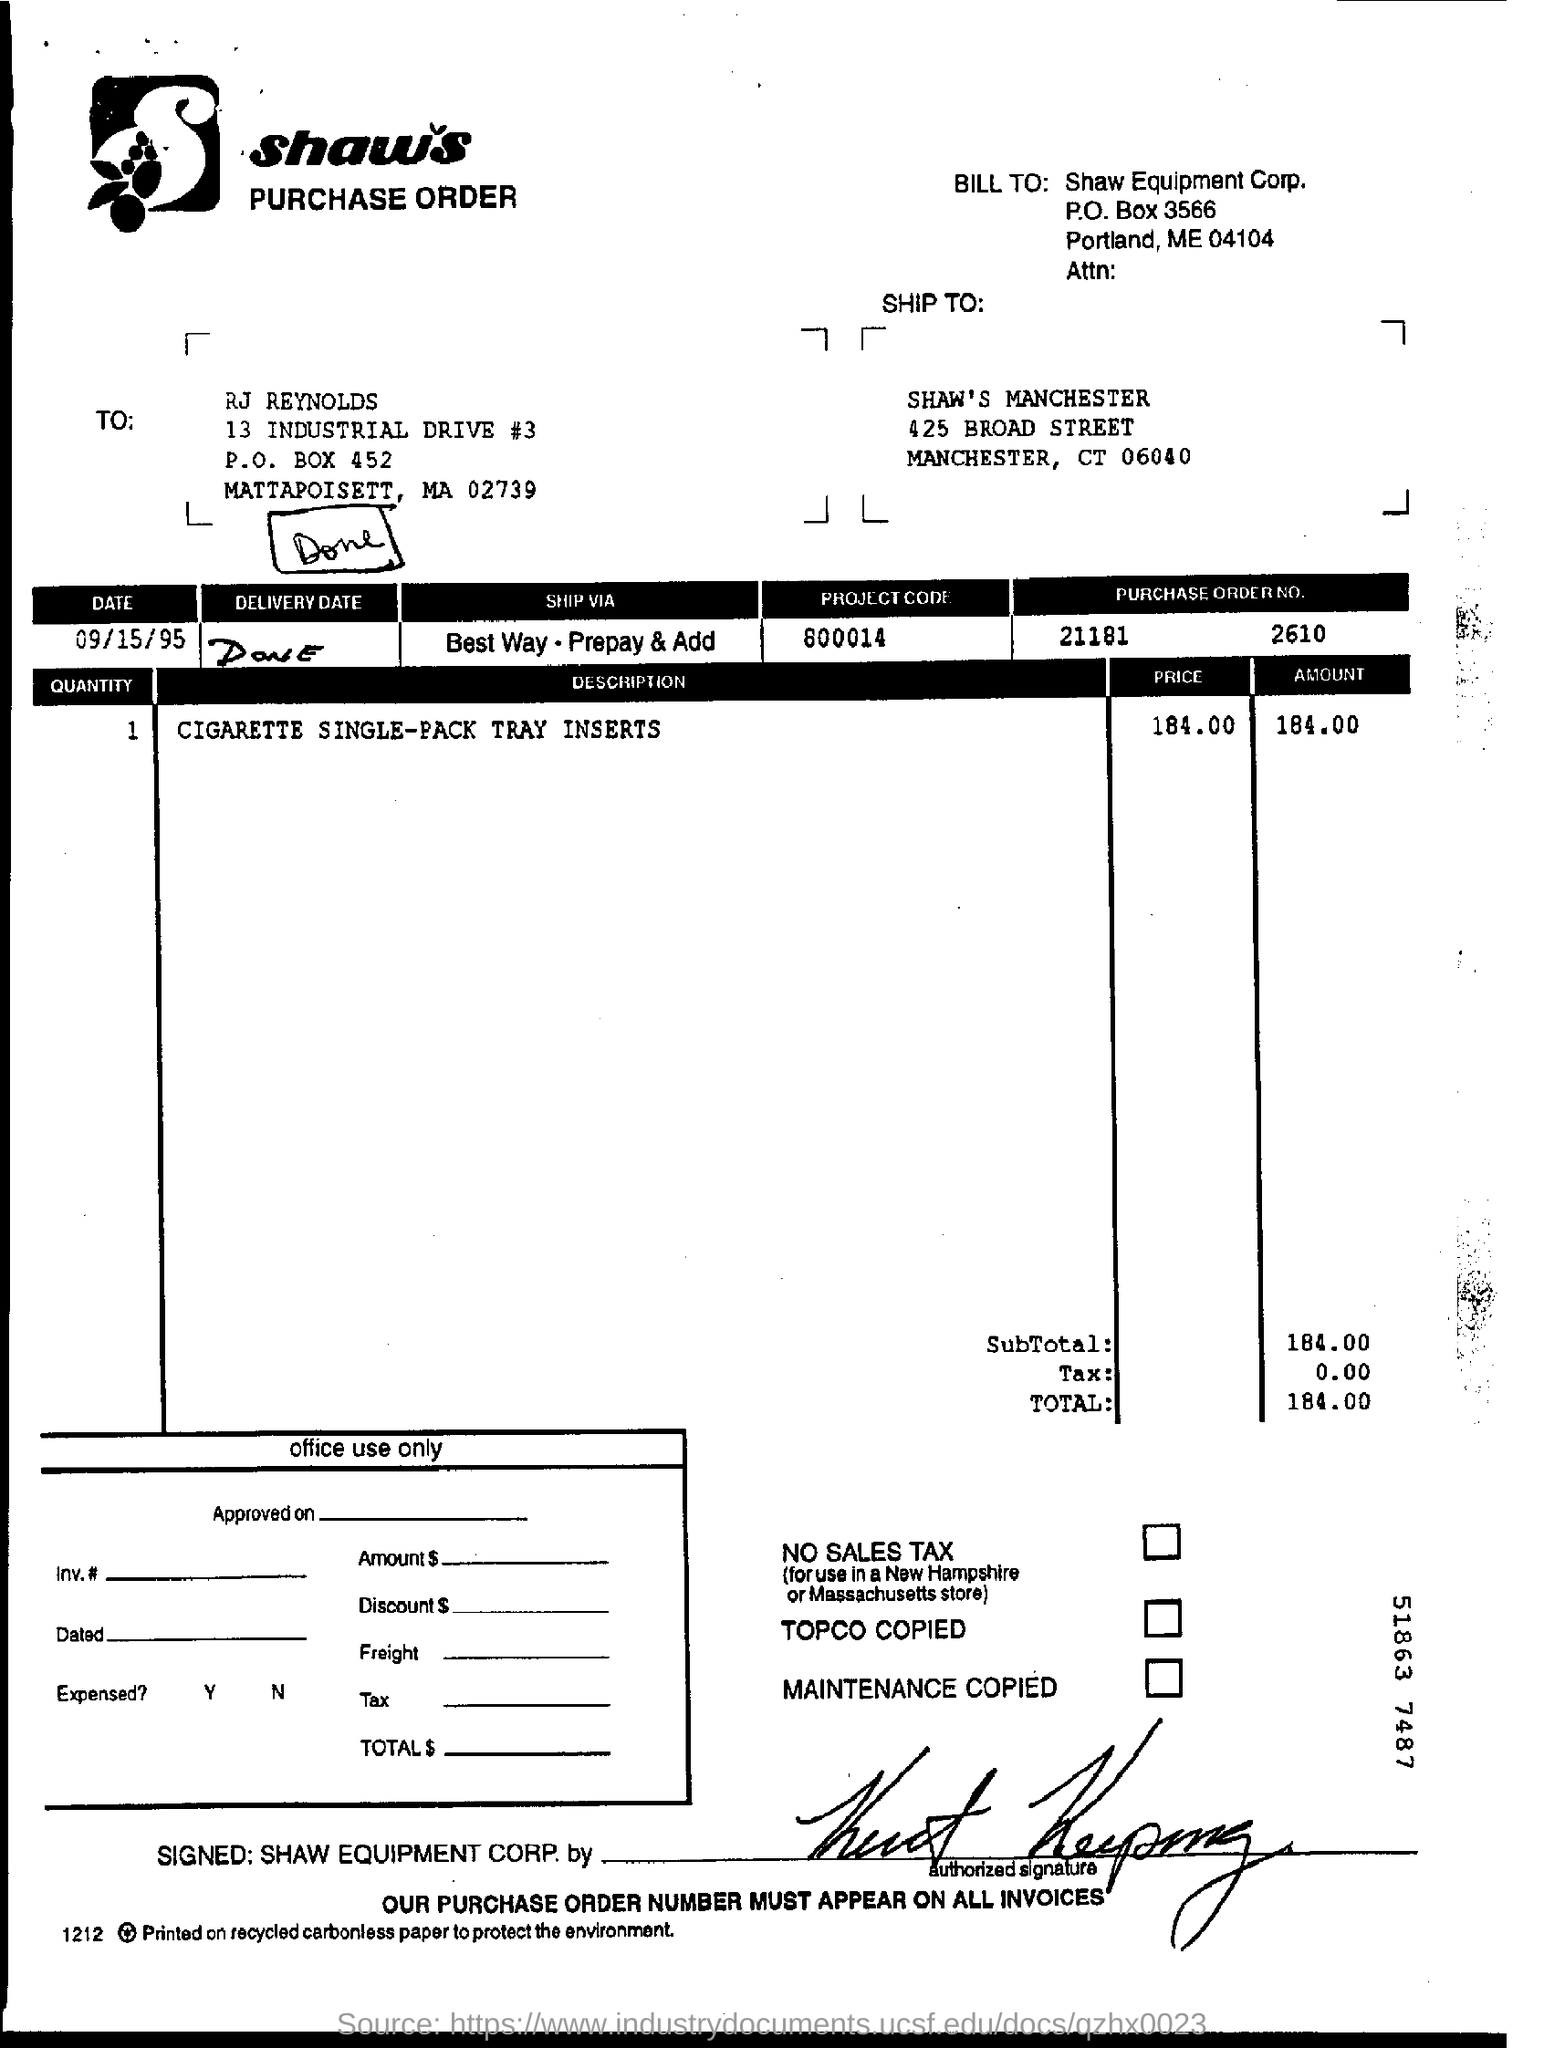List a handful of essential elements in this visual. The question "What is the purchase order number?" refers to a specific piece of information about an order or transaction, and the answer is provided in the form of a numerical sequence: 21181 and 2610. What is the project code? It is 800014... The date mentioned is September 15, 1995. 